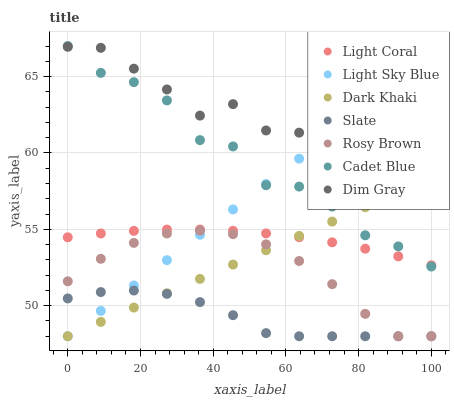Does Slate have the minimum area under the curve?
Answer yes or no. Yes. Does Dim Gray have the maximum area under the curve?
Answer yes or no. Yes. Does Cadet Blue have the minimum area under the curve?
Answer yes or no. No. Does Cadet Blue have the maximum area under the curve?
Answer yes or no. No. Is Light Sky Blue the smoothest?
Answer yes or no. Yes. Is Cadet Blue the roughest?
Answer yes or no. Yes. Is Slate the smoothest?
Answer yes or no. No. Is Slate the roughest?
Answer yes or no. No. Does Dark Khaki have the lowest value?
Answer yes or no. Yes. Does Cadet Blue have the lowest value?
Answer yes or no. No. Does Cadet Blue have the highest value?
Answer yes or no. Yes. Does Slate have the highest value?
Answer yes or no. No. Is Slate less than Cadet Blue?
Answer yes or no. Yes. Is Cadet Blue greater than Slate?
Answer yes or no. Yes. Does Light Coral intersect Light Sky Blue?
Answer yes or no. Yes. Is Light Coral less than Light Sky Blue?
Answer yes or no. No. Is Light Coral greater than Light Sky Blue?
Answer yes or no. No. Does Slate intersect Cadet Blue?
Answer yes or no. No. 